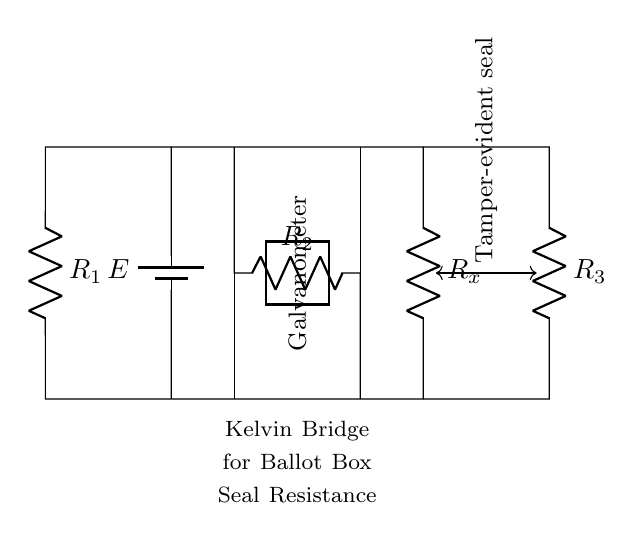What type of bridge is represented in this circuit? The circuit is a Kelvin Bridge, which is specifically designed for measuring low resistances. It features specific components that allow for this purpose.
Answer: Kelvin Bridge What is the purpose of the galvanometer in this circuit? The galvanometer measures the current flowing through it, which would be affected by the balance of the bridge. If the bridge is balanced, no current flows through the galvanometer.
Answer: Measure current How many resistors are present in this circuit? There are four resistors in the circuit labeled R1, R2, R3, and Rx.
Answer: Four What does the voltage source in this circuit represent? The voltage source provides the electromotive force required for the circuit to operate, allowing current to flow through the resistors and galvanometer.
Answer: Provide electromotive force How is the tamper-evident seal integrated into this circuit? The tamper-evident seal is represented as an external connection that affects the resistance Rx in the bridge, as it regulates the voltage measured through the galvanometer.
Answer: Affects resistance What does a balanced Kelvin Bridge indicate about the unknown resistance? A balanced Kelvin Bridge indicates that the unknown resistance (Rx) is equal to the ratio of the known resistances R1, R2, and R3, allowing for accurate measurement without influence from contact or lead resistances.
Answer: Accurate measurement 